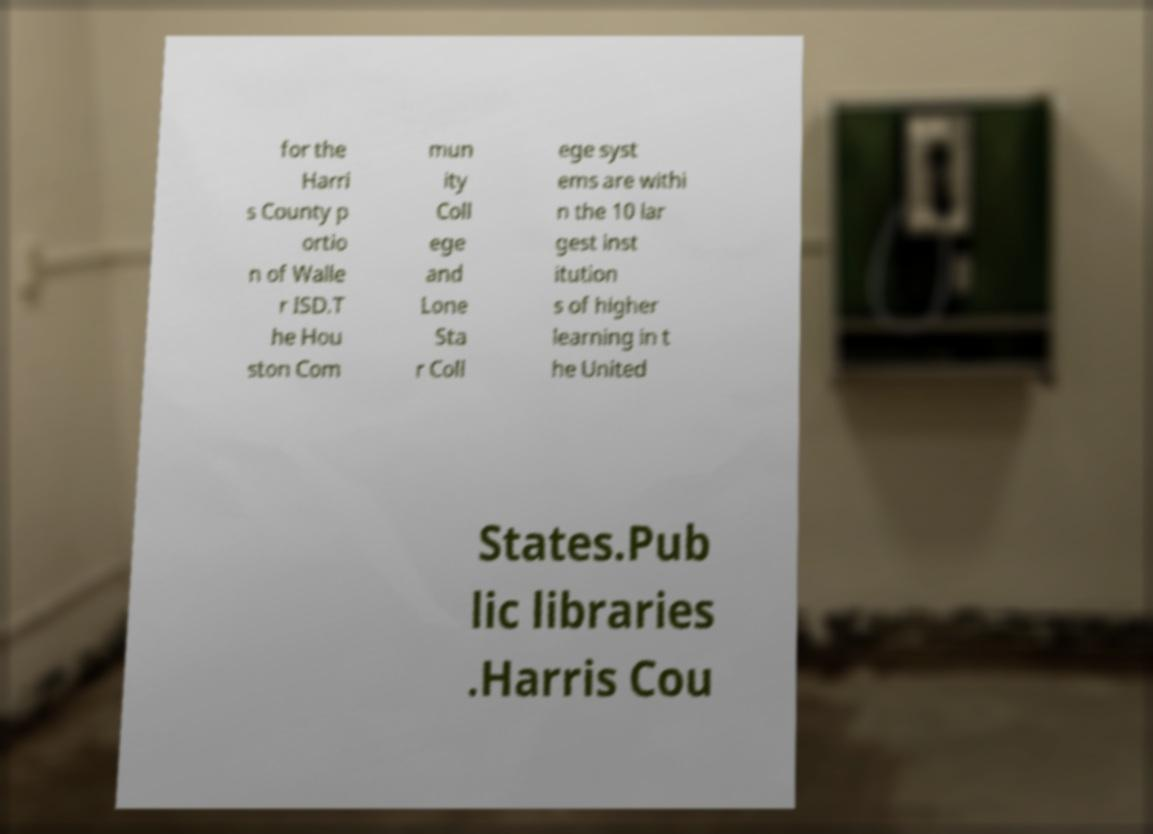There's text embedded in this image that I need extracted. Can you transcribe it verbatim? for the Harri s County p ortio n of Walle r ISD.T he Hou ston Com mun ity Coll ege and Lone Sta r Coll ege syst ems are withi n the 10 lar gest inst itution s of higher learning in t he United States.Pub lic libraries .Harris Cou 